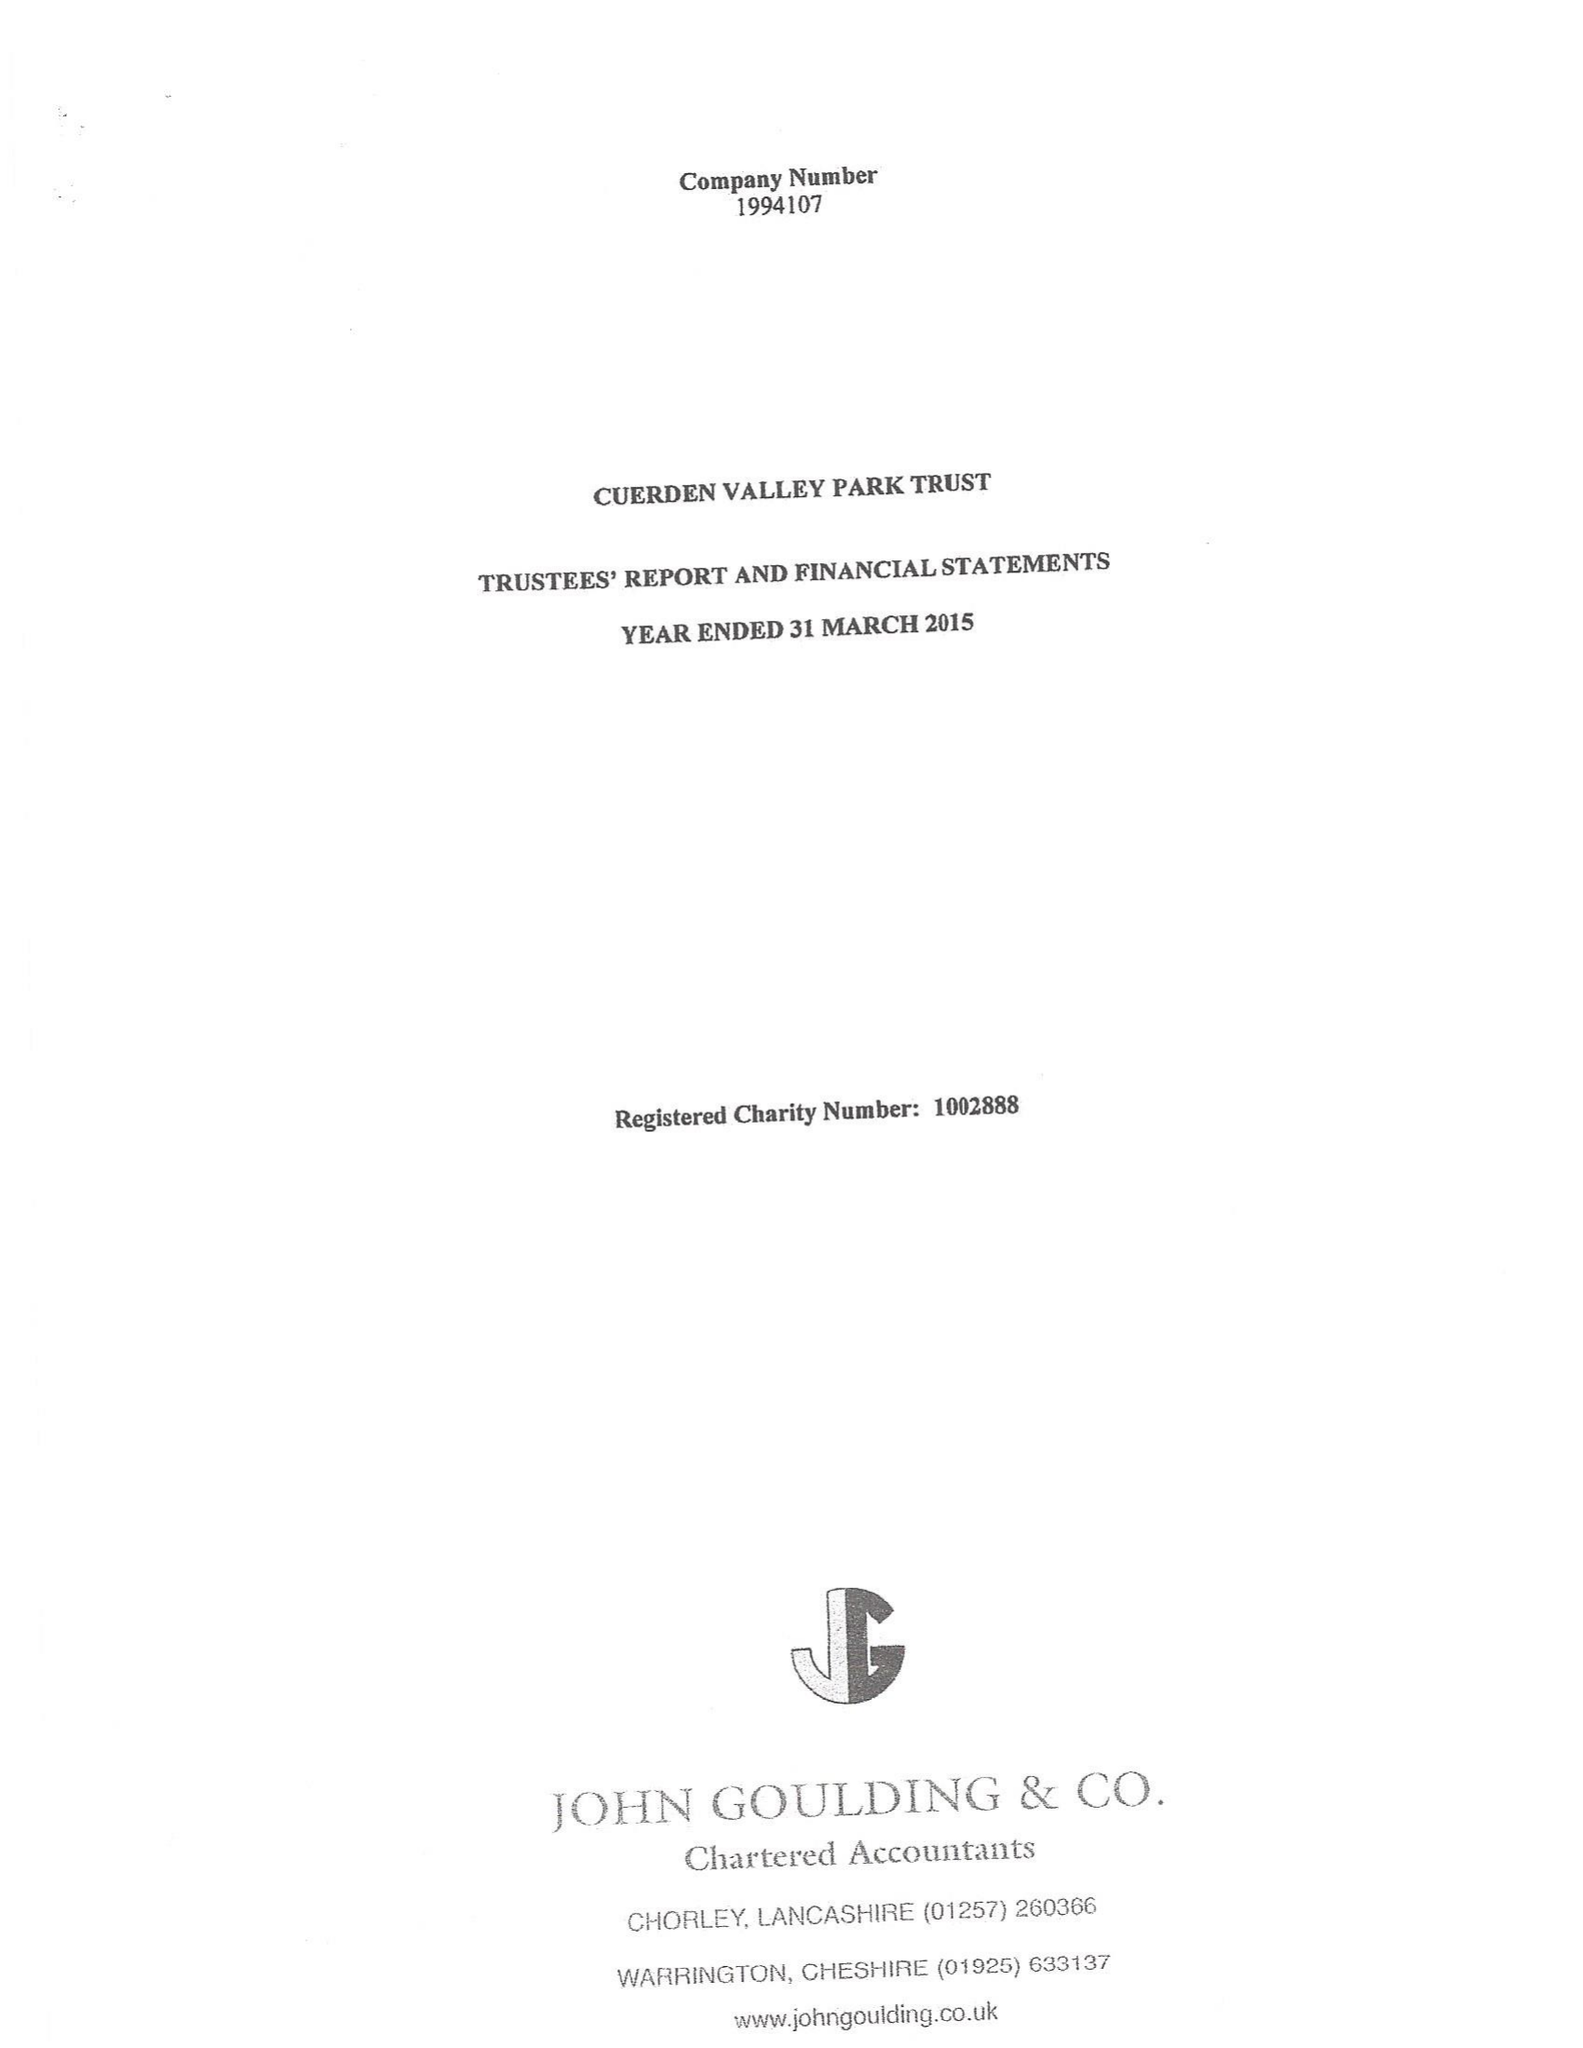What is the value for the address__postcode?
Answer the question using a single word or phrase. PR5 6BY 